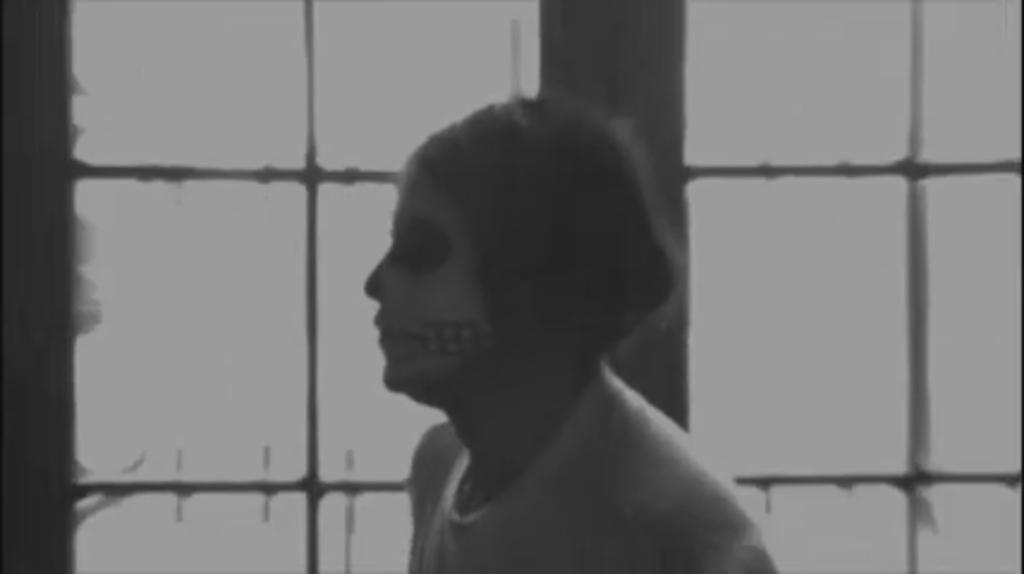What is the color scheme of the image? The image is black and white. Who is the main subject in the image? There is a girl in the middle of the image. What can be seen in the background of the image? There is a window in the background of the image. What is unique about the girl's appearance in the image? There is a painting on the girl's face. What flavor of ice cream does the girl prefer, based on her behavior in the image? There is no ice cream or indication of the girl's behavior in the image, so we cannot determine her ice cream preference. Can you see any bones in the image? There are no bones visible in the image. 